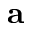<formula> <loc_0><loc_0><loc_500><loc_500>a</formula> 